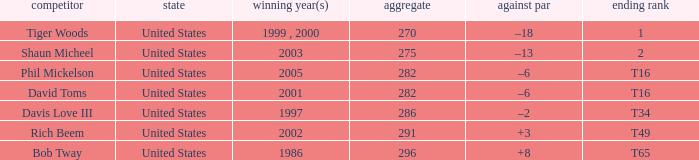In what place did Phil Mickelson finish with a total of 282? T16. 